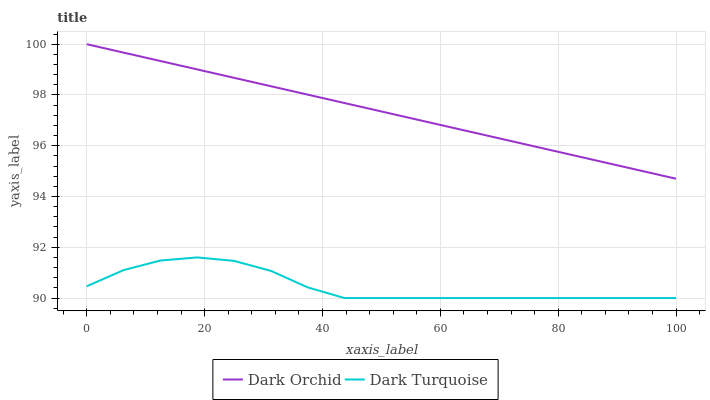Does Dark Turquoise have the minimum area under the curve?
Answer yes or no. Yes. Does Dark Orchid have the maximum area under the curve?
Answer yes or no. Yes. Does Dark Orchid have the minimum area under the curve?
Answer yes or no. No. Is Dark Orchid the smoothest?
Answer yes or no. Yes. Is Dark Turquoise the roughest?
Answer yes or no. Yes. Is Dark Orchid the roughest?
Answer yes or no. No. Does Dark Turquoise have the lowest value?
Answer yes or no. Yes. Does Dark Orchid have the lowest value?
Answer yes or no. No. Does Dark Orchid have the highest value?
Answer yes or no. Yes. Is Dark Turquoise less than Dark Orchid?
Answer yes or no. Yes. Is Dark Orchid greater than Dark Turquoise?
Answer yes or no. Yes. Does Dark Turquoise intersect Dark Orchid?
Answer yes or no. No. 